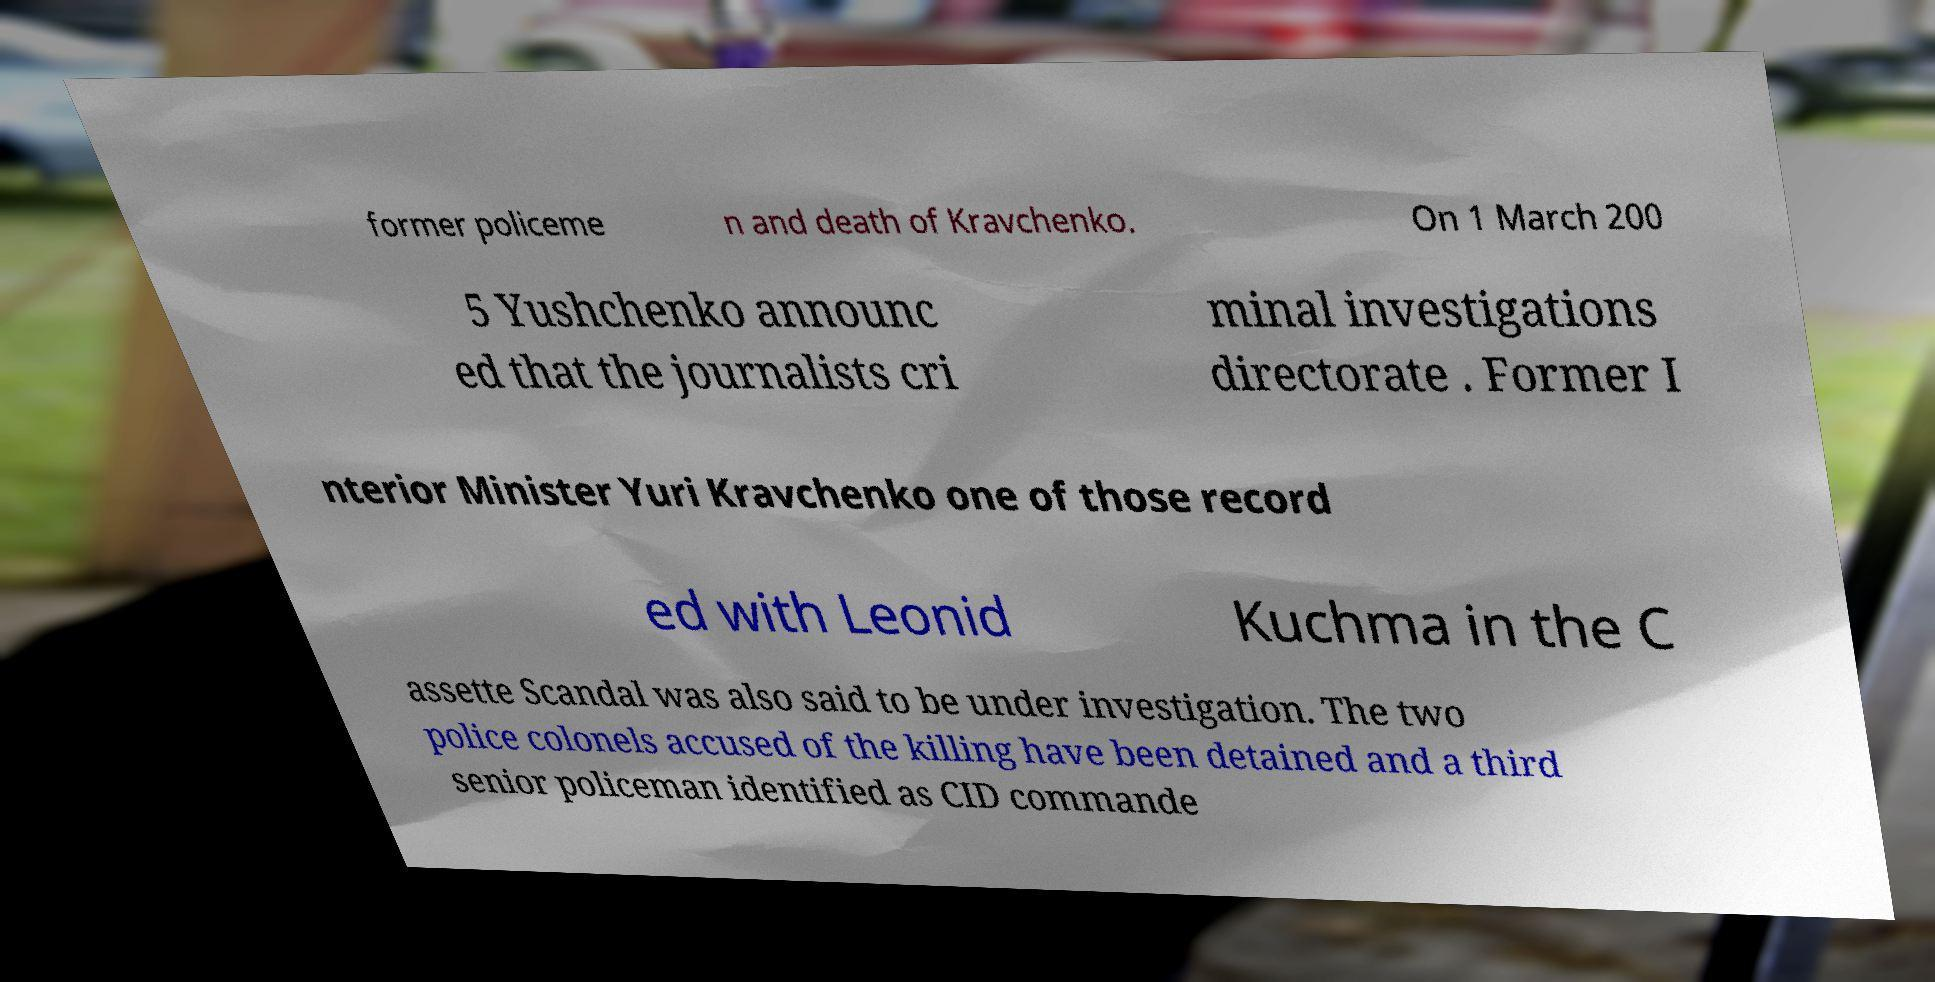Could you extract and type out the text from this image? former policeme n and death of Kravchenko. On 1 March 200 5 Yushchenko announc ed that the journalists cri minal investigations directorate . Former I nterior Minister Yuri Kravchenko one of those record ed with Leonid Kuchma in the C assette Scandal was also said to be under investigation. The two police colonels accused of the killing have been detained and a third senior policeman identified as CID commande 